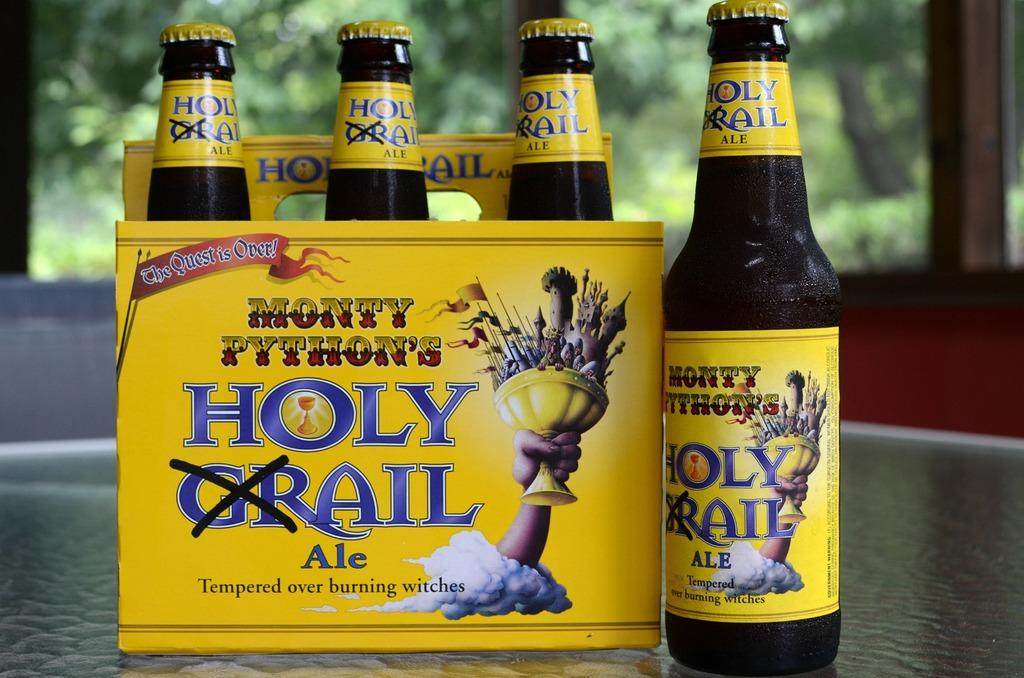<image>
Render a clear and concise summary of the photo. A bottle of Monty Python's Holy Ale is next to a box of it. 